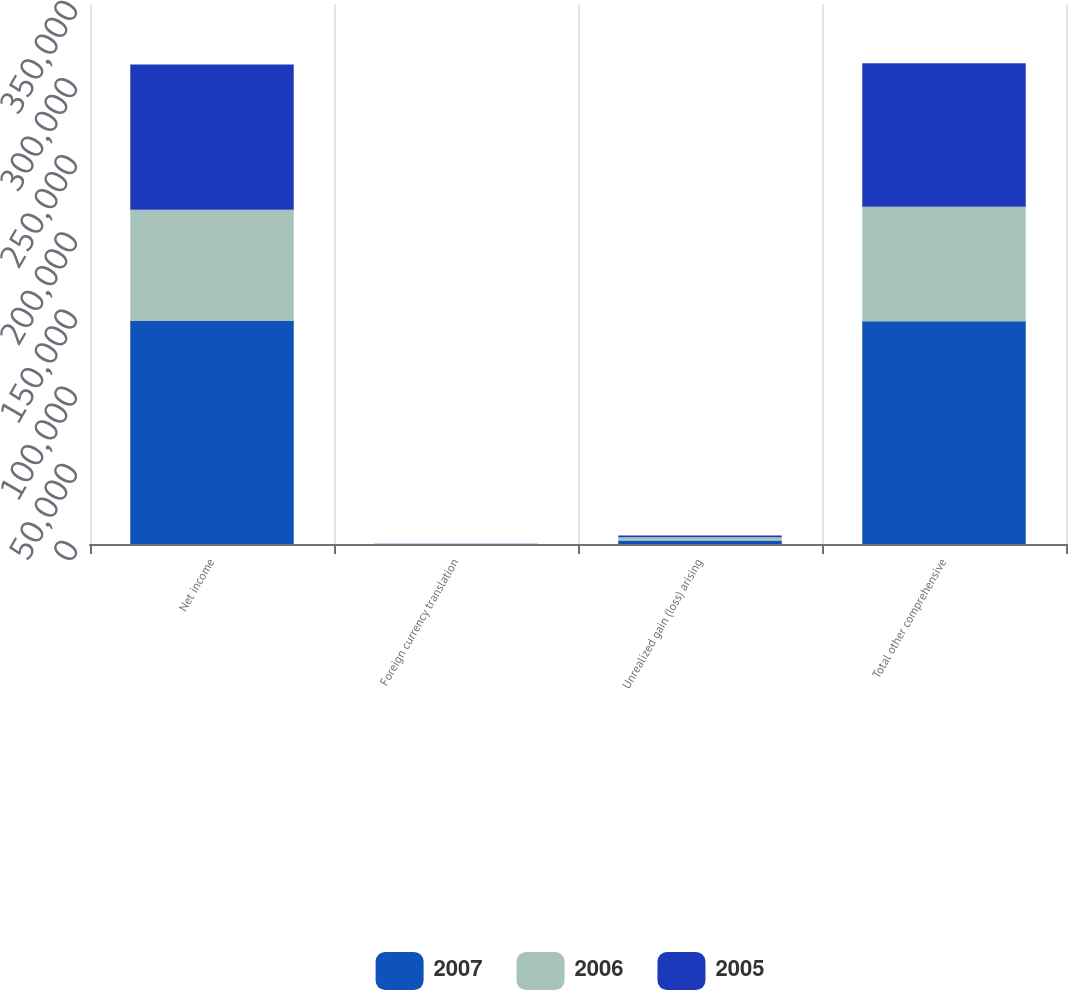<chart> <loc_0><loc_0><loc_500><loc_500><stacked_bar_chart><ecel><fcel>Net income<fcel>Foreign currency translation<fcel>Unrealized gain (loss) arising<fcel>Total other comprehensive<nl><fcel>2007<fcel>144537<fcel>12<fcel>2258<fcel>144362<nl><fcel>2006<fcel>72044<fcel>22<fcel>2160<fcel>74226<nl><fcel>2005<fcel>94134<fcel>49<fcel>1134<fcel>93049<nl></chart> 